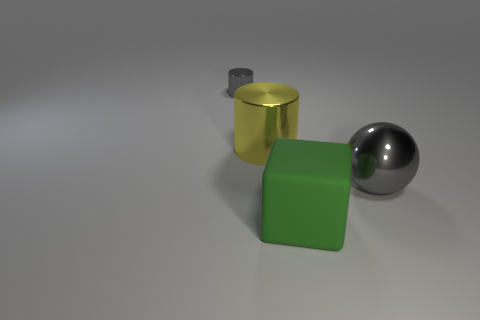There is a gray thing behind the large gray object; does it have the same size as the gray object that is in front of the tiny gray metallic thing?
Make the answer very short. No. How many other objects are there of the same material as the large gray object?
Your answer should be compact. 2. What number of shiny things are large cubes or yellow cylinders?
Provide a succinct answer. 1. Is the number of large green things less than the number of metal cylinders?
Keep it short and to the point. Yes. There is a gray shiny cylinder; is its size the same as the gray metallic object that is to the right of the yellow cylinder?
Your response must be concise. No. Is there anything else that has the same shape as the yellow thing?
Give a very brief answer. Yes. The metal ball is what size?
Your answer should be very brief. Large. Are there fewer cylinders that are right of the big green matte cube than small metallic things?
Your response must be concise. Yes. Does the yellow thing have the same size as the gray cylinder?
Keep it short and to the point. No. Are there any other things that have the same size as the yellow thing?
Offer a terse response. Yes. 